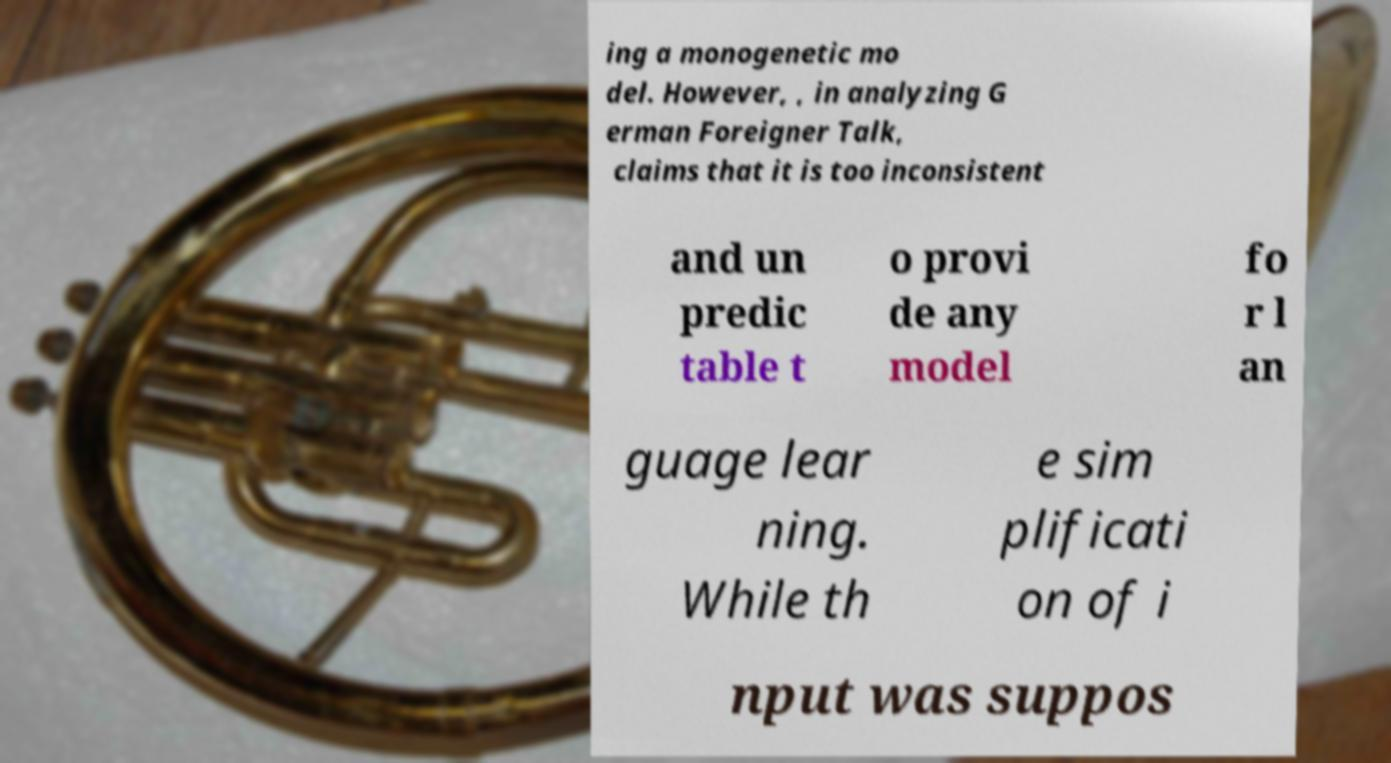Could you assist in decoding the text presented in this image and type it out clearly? ing a monogenetic mo del. However, , in analyzing G erman Foreigner Talk, claims that it is too inconsistent and un predic table t o provi de any model fo r l an guage lear ning. While th e sim plificati on of i nput was suppos 